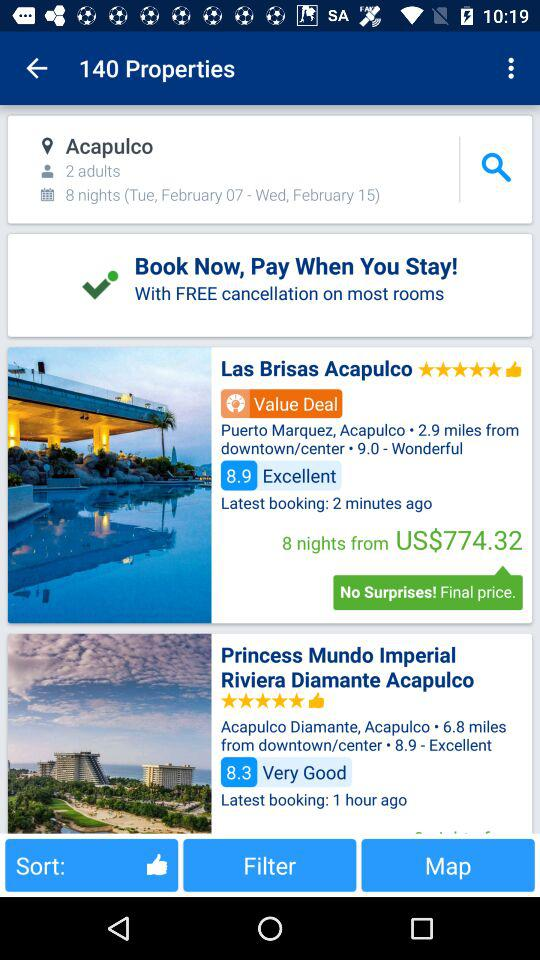What is the total number of properties? The total number of properties is 140. 